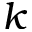Convert formula to latex. <formula><loc_0><loc_0><loc_500><loc_500>k</formula> 